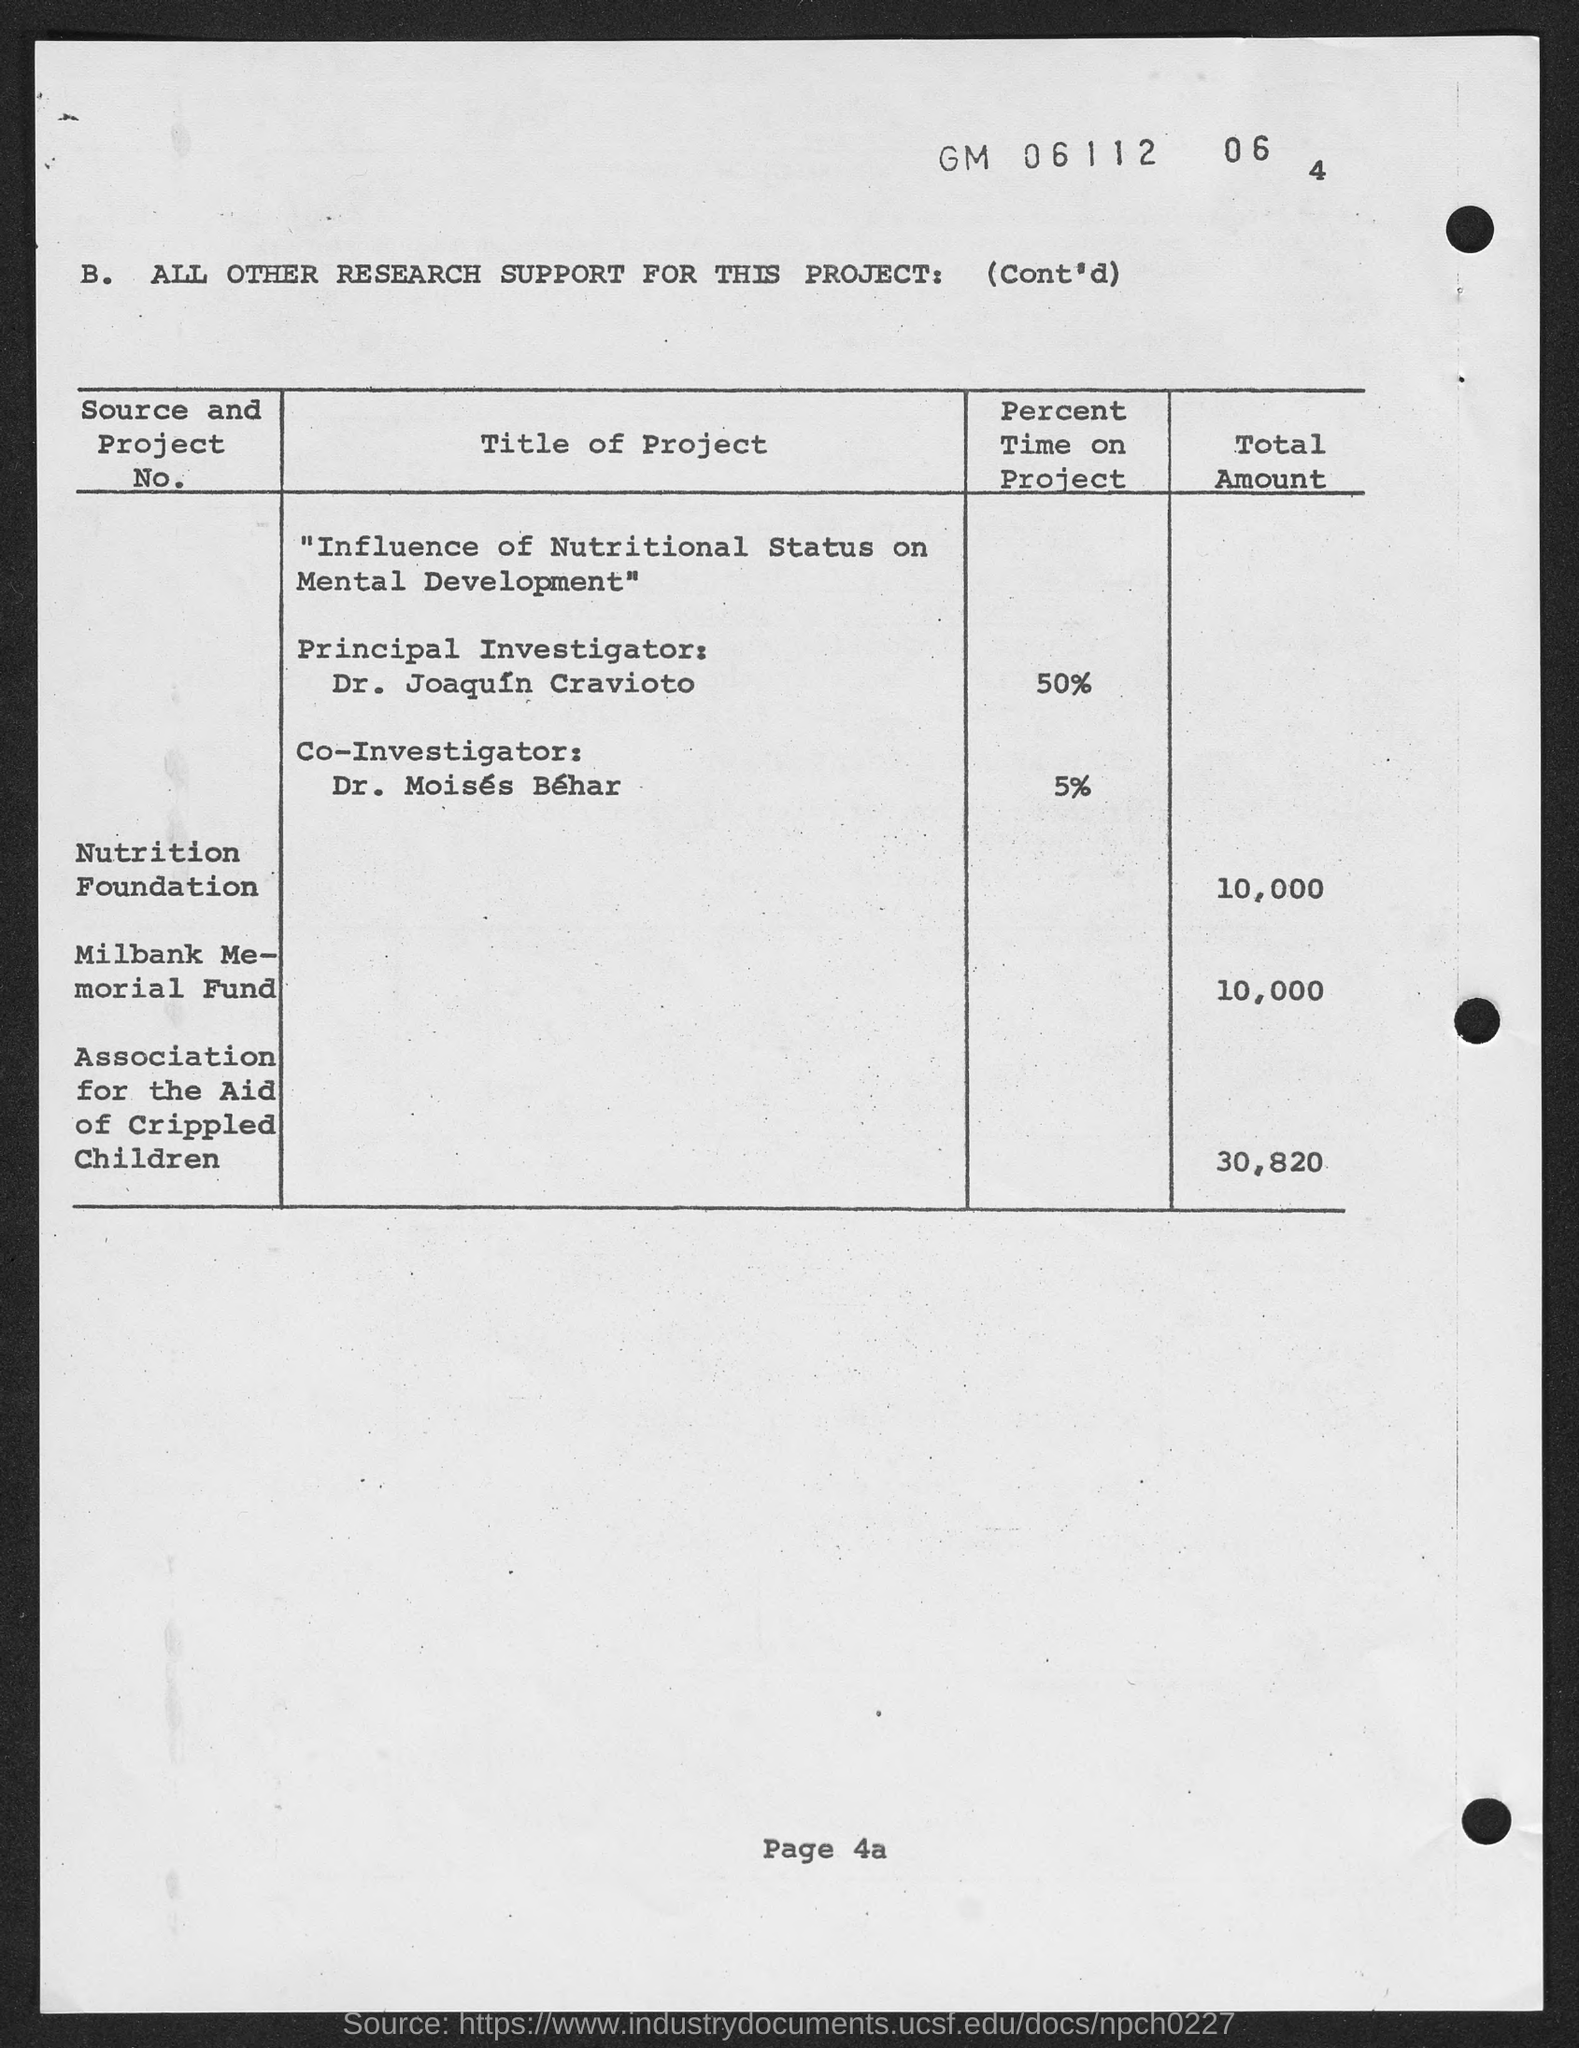Outline some significant characteristics in this image. The Association for the Aid of Crippled Children has provided a total of $30,820 for this project. The page number mentioned in this document is 4a.. The Milbank Memorial Fund has provided a total of $10,000 for this project. The co-investigator for the project titled "Influence of Nutritional Status on Mental Development" is Dr. Moises Behar. The Nutrition Foundation has funded a total of $10,000 for this project. 